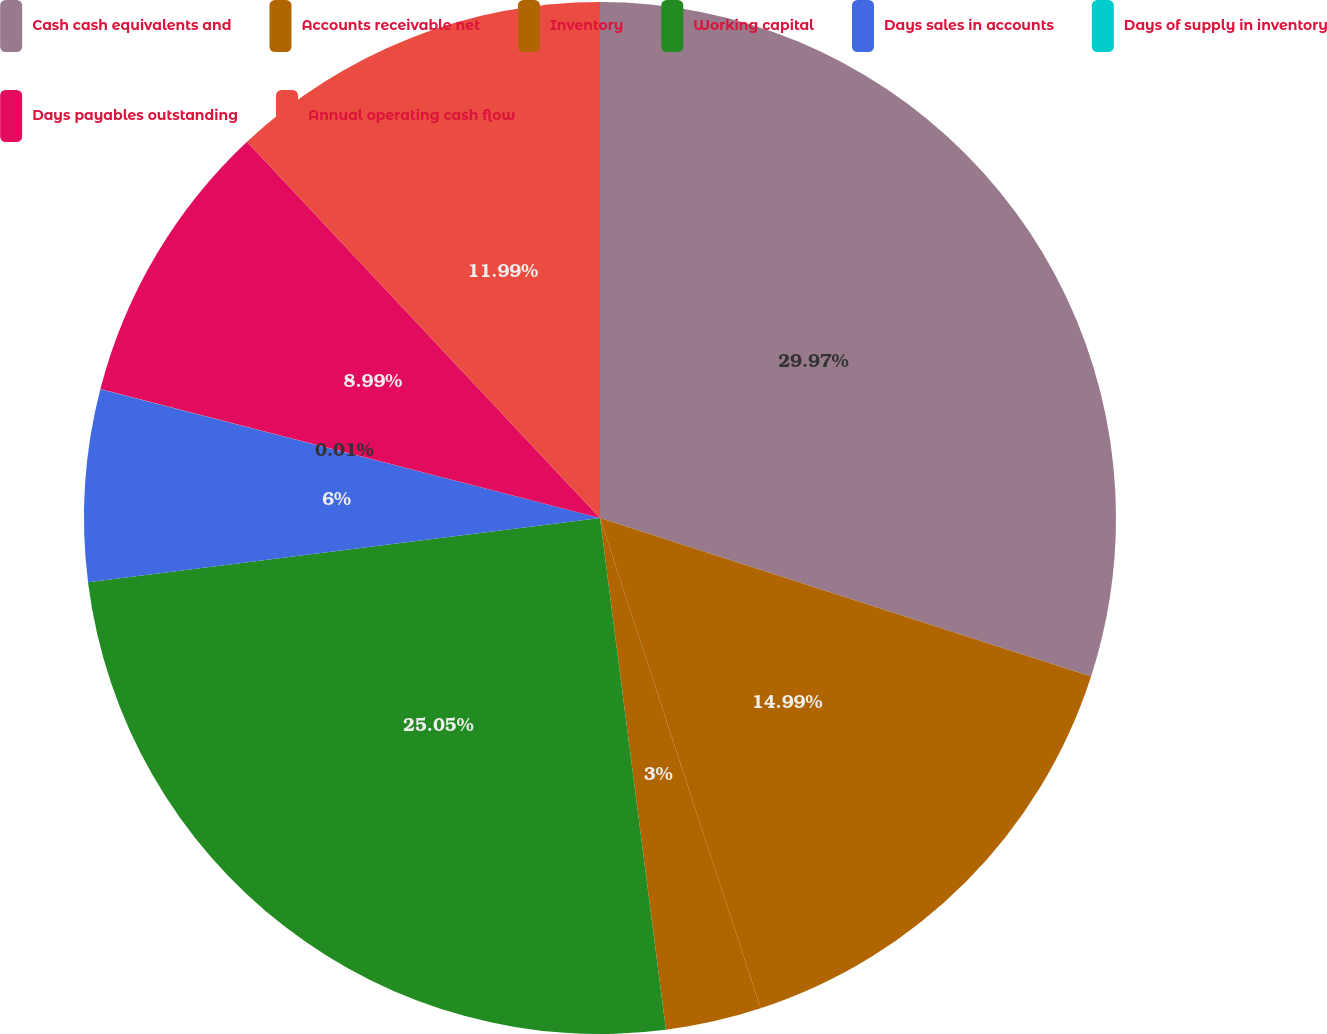Convert chart. <chart><loc_0><loc_0><loc_500><loc_500><pie_chart><fcel>Cash cash equivalents and<fcel>Accounts receivable net<fcel>Inventory<fcel>Working capital<fcel>Days sales in accounts<fcel>Days of supply in inventory<fcel>Days payables outstanding<fcel>Annual operating cash flow<nl><fcel>29.97%<fcel>14.99%<fcel>3.0%<fcel>25.05%<fcel>6.0%<fcel>0.01%<fcel>8.99%<fcel>11.99%<nl></chart> 